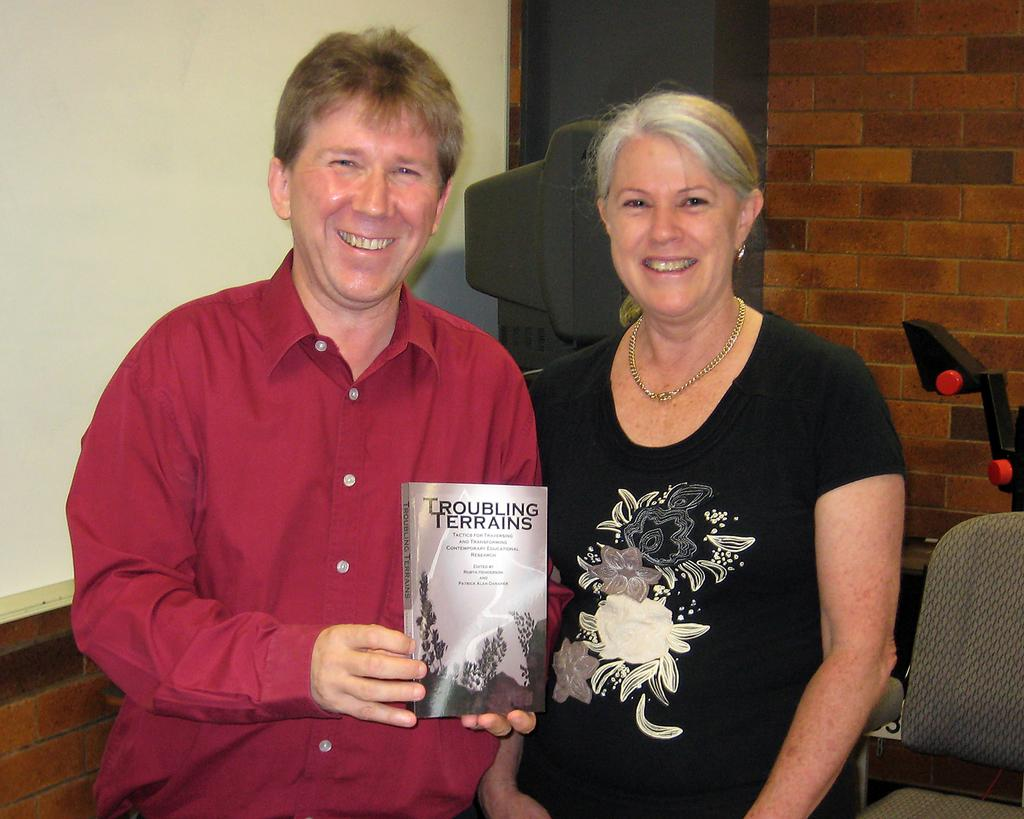<image>
Share a concise interpretation of the image provided. a man and a woman standing behind a book titled 'troubling terrains' 